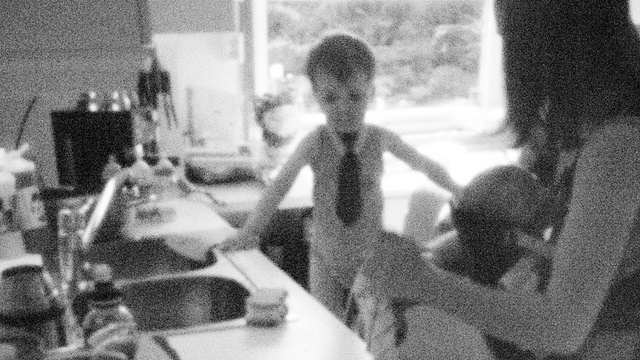Describe the objects in this image and their specific colors. I can see people in gray, black, and lightgray tones, people in gray, darkgray, black, and lightgray tones, people in gray, black, darkgray, and lightgray tones, sink in gray, black, and lightgray tones, and sink in gray, black, darkgray, and lightgray tones in this image. 